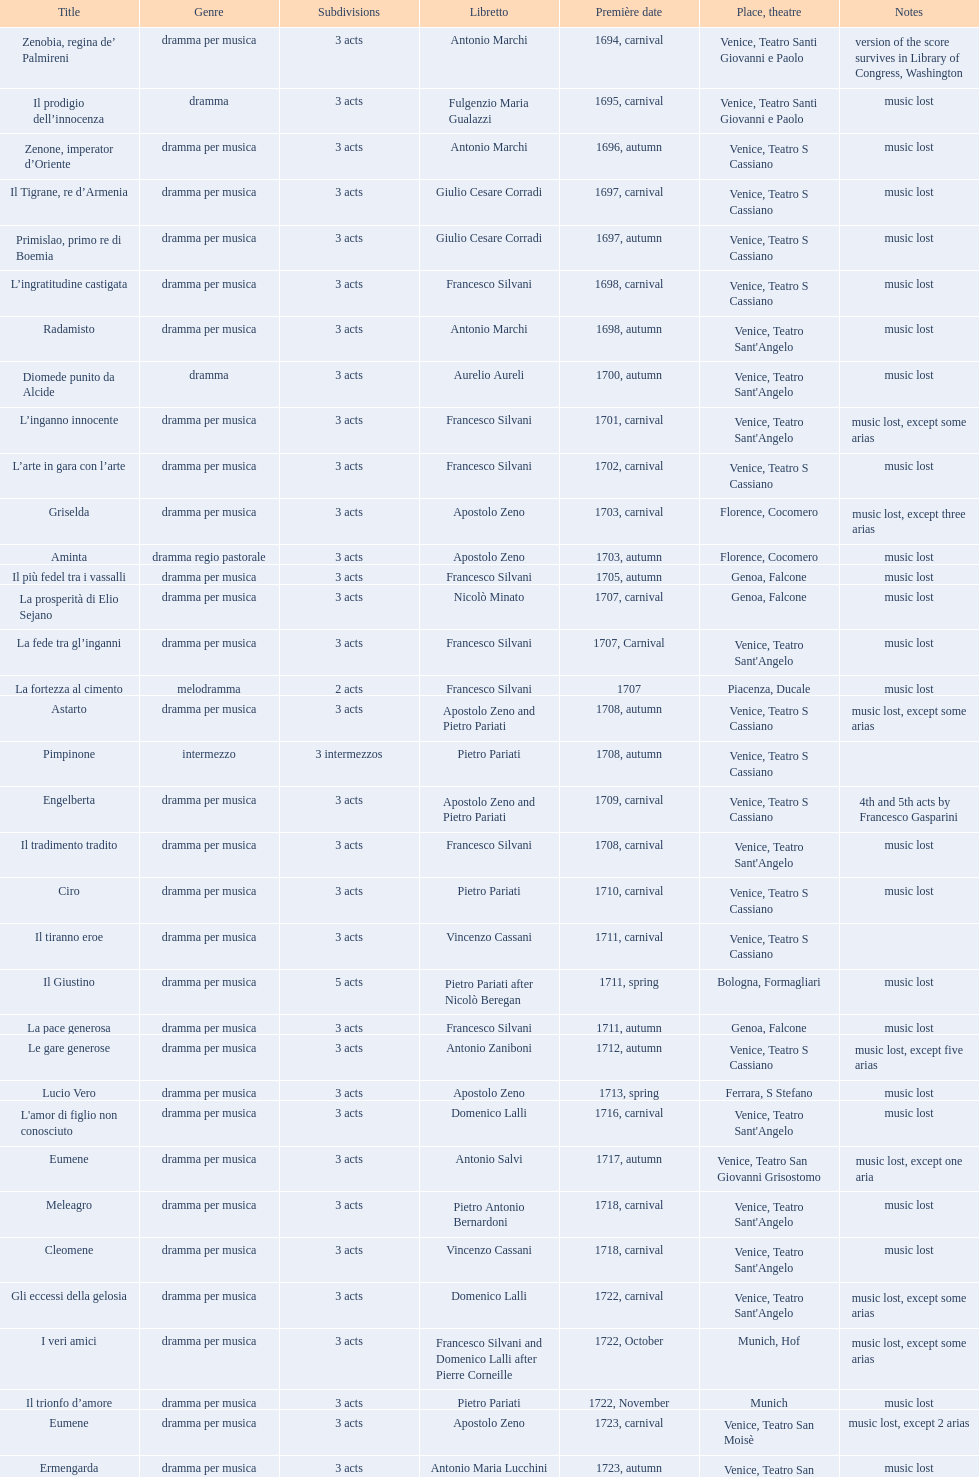What title made its debut right after candide? Artamene. 